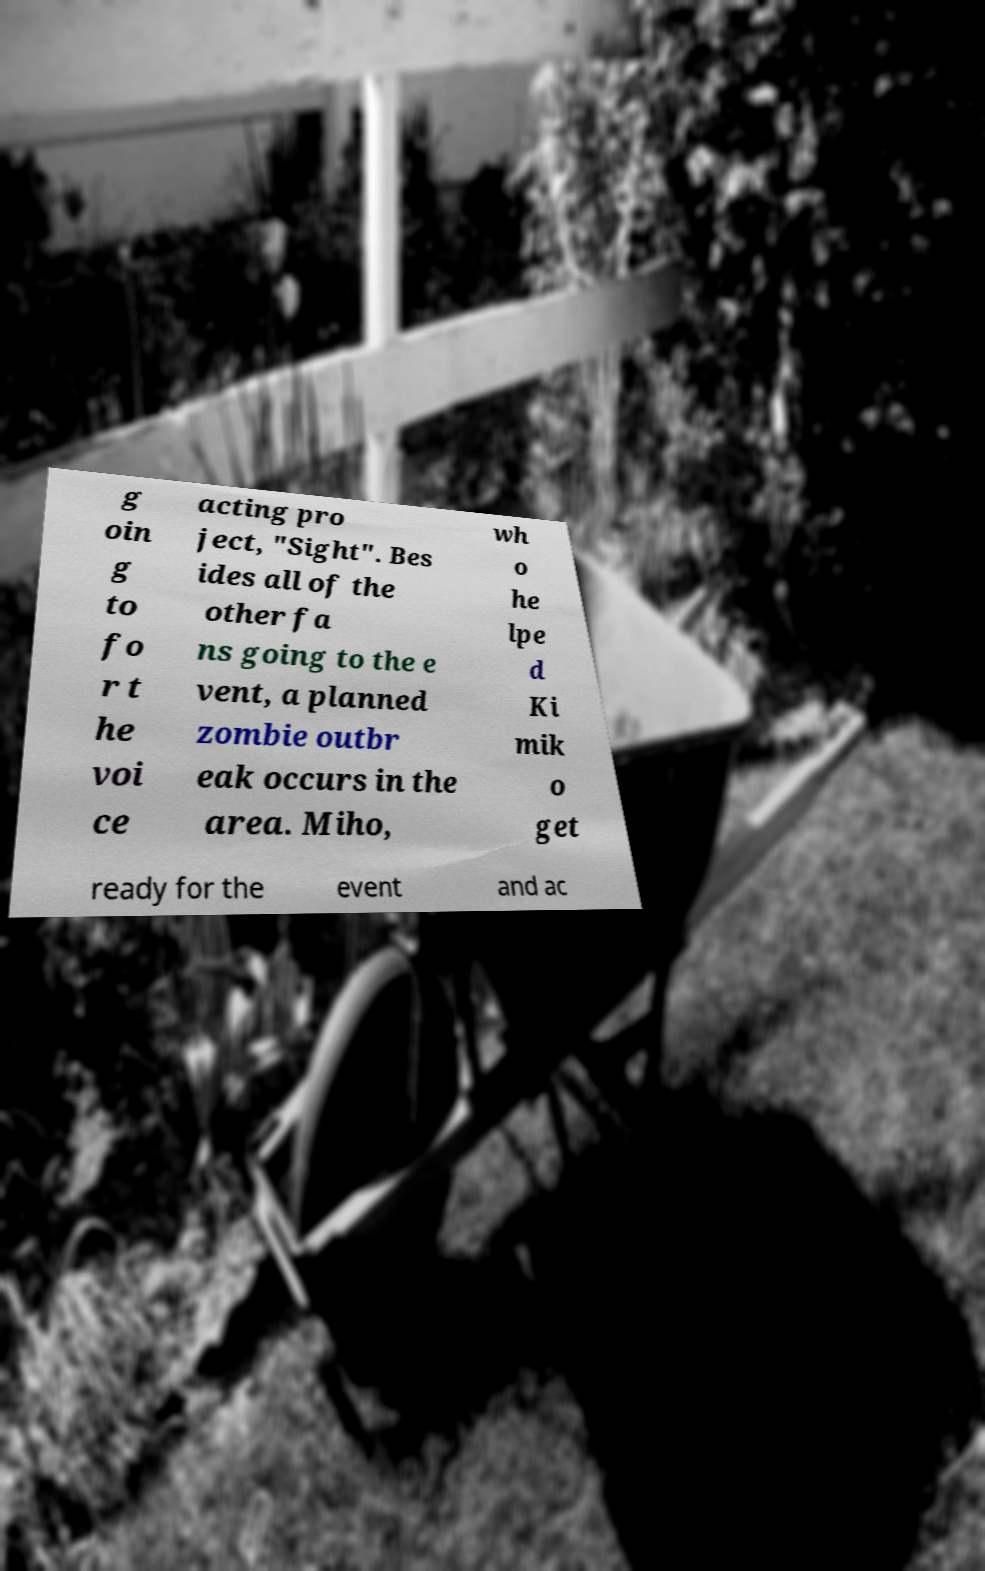For documentation purposes, I need the text within this image transcribed. Could you provide that? g oin g to fo r t he voi ce acting pro ject, "Sight". Bes ides all of the other fa ns going to the e vent, a planned zombie outbr eak occurs in the area. Miho, wh o he lpe d Ki mik o get ready for the event and ac 